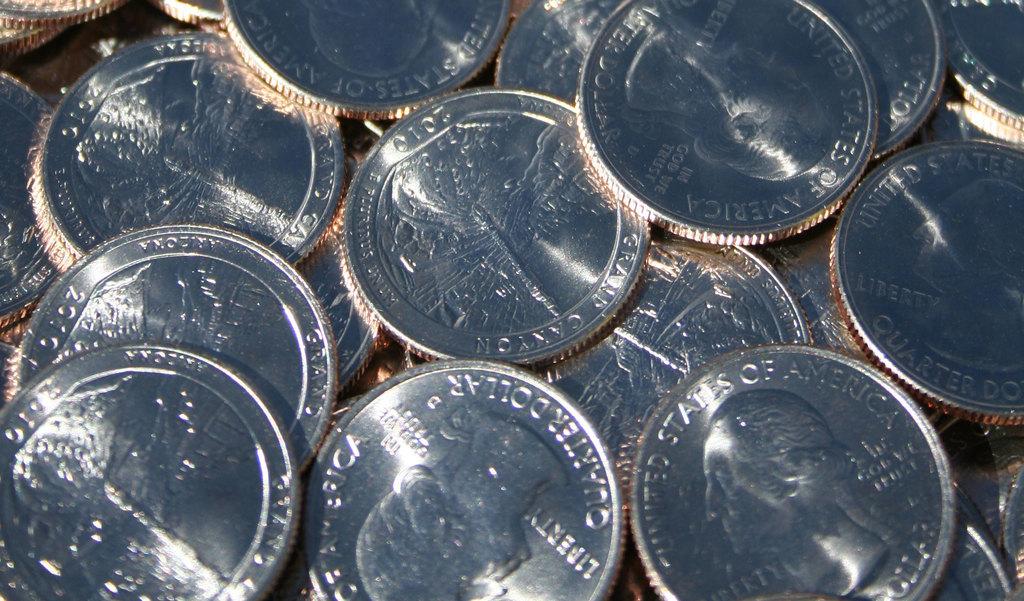What contry are these coins from?
Offer a terse response. United states of america. How much is each coin worth?
Give a very brief answer. 25 cents. 